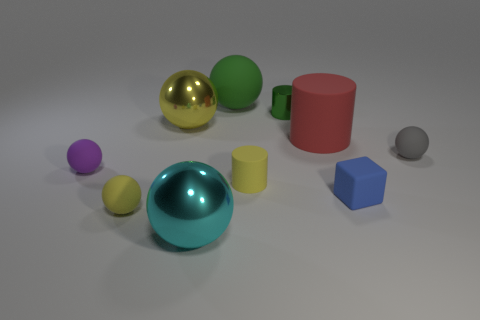Are there any gray things that have the same size as the shiny cylinder?
Provide a short and direct response. Yes. The tiny shiny object is what color?
Keep it short and to the point. Green. There is a matte object to the left of the yellow rubber object that is on the left side of the yellow metal thing; what is its color?
Your answer should be very brief. Purple. What shape is the rubber object on the left side of the small yellow matte object to the left of the rubber sphere behind the tiny green cylinder?
Offer a terse response. Sphere. What number of purple spheres are made of the same material as the yellow cylinder?
Offer a terse response. 1. There is a tiny rubber ball to the right of the tiny yellow matte sphere; what number of small purple objects are behind it?
Give a very brief answer. 0. How many big purple matte balls are there?
Offer a very short reply. 0. Do the cyan ball and the yellow thing to the left of the yellow shiny ball have the same material?
Make the answer very short. No. Do the metallic object that is on the right side of the green matte object and the tiny matte cylinder have the same color?
Offer a terse response. No. What is the object that is both on the right side of the small yellow cylinder and behind the big yellow object made of?
Offer a very short reply. Metal. 